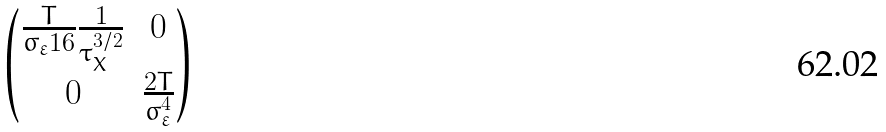<formula> <loc_0><loc_0><loc_500><loc_500>\begin{pmatrix} \frac { T } { \sigma _ { \varepsilon } 1 6 } \frac { 1 } { \tau _ { X } ^ { 3 / 2 } } & 0 \\ 0 & \frac { 2 T } { \sigma ^ { 4 } _ { \varepsilon } } \end{pmatrix}</formula> 